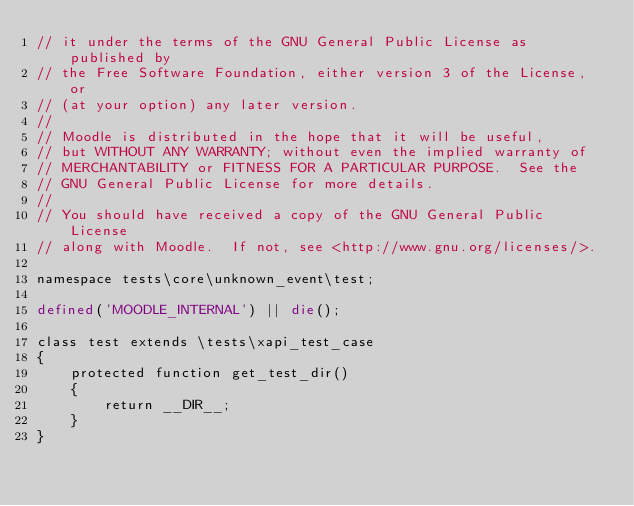Convert code to text. <code><loc_0><loc_0><loc_500><loc_500><_PHP_>// it under the terms of the GNU General Public License as published by
// the Free Software Foundation, either version 3 of the License, or
// (at your option) any later version.
//
// Moodle is distributed in the hope that it will be useful,
// but WITHOUT ANY WARRANTY; without even the implied warranty of
// MERCHANTABILITY or FITNESS FOR A PARTICULAR PURPOSE.  See the
// GNU General Public License for more details.
//
// You should have received a copy of the GNU General Public License
// along with Moodle.  If not, see <http://www.gnu.org/licenses/>.

namespace tests\core\unknown_event\test;

defined('MOODLE_INTERNAL') || die();

class test extends \tests\xapi_test_case
{
    protected function get_test_dir()
    {
        return __DIR__;
    }
}
</code> 